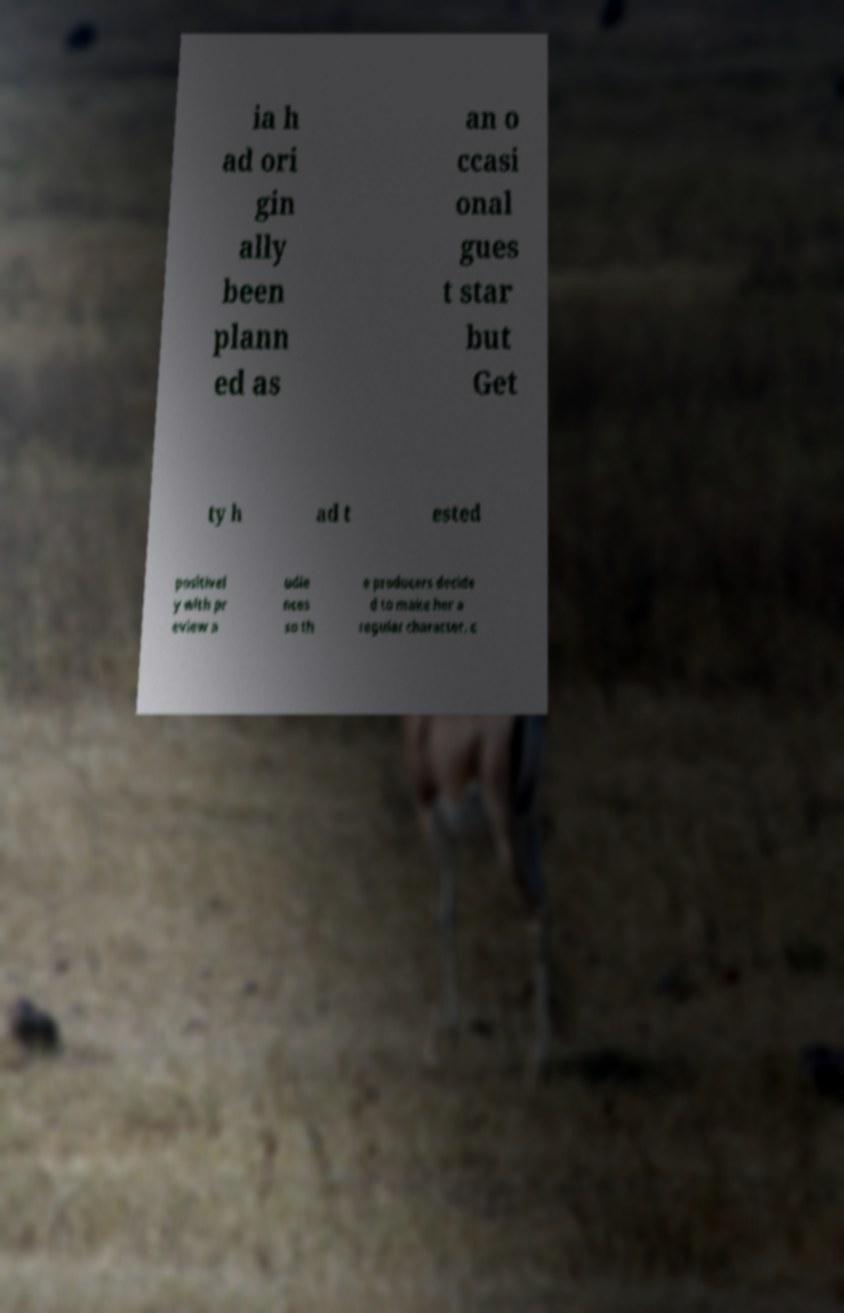Can you accurately transcribe the text from the provided image for me? ia h ad ori gin ally been plann ed as an o ccasi onal gues t star but Get ty h ad t ested positivel y with pr eview a udie nces so th e producers decide d to make her a regular character. c 